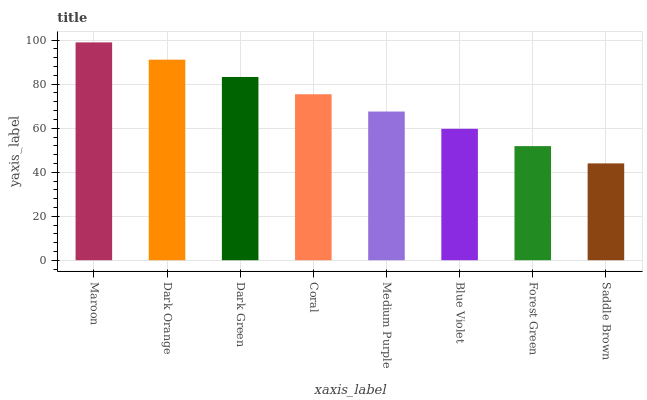Is Saddle Brown the minimum?
Answer yes or no. Yes. Is Maroon the maximum?
Answer yes or no. Yes. Is Dark Orange the minimum?
Answer yes or no. No. Is Dark Orange the maximum?
Answer yes or no. No. Is Maroon greater than Dark Orange?
Answer yes or no. Yes. Is Dark Orange less than Maroon?
Answer yes or no. Yes. Is Dark Orange greater than Maroon?
Answer yes or no. No. Is Maroon less than Dark Orange?
Answer yes or no. No. Is Coral the high median?
Answer yes or no. Yes. Is Medium Purple the low median?
Answer yes or no. Yes. Is Medium Purple the high median?
Answer yes or no. No. Is Saddle Brown the low median?
Answer yes or no. No. 